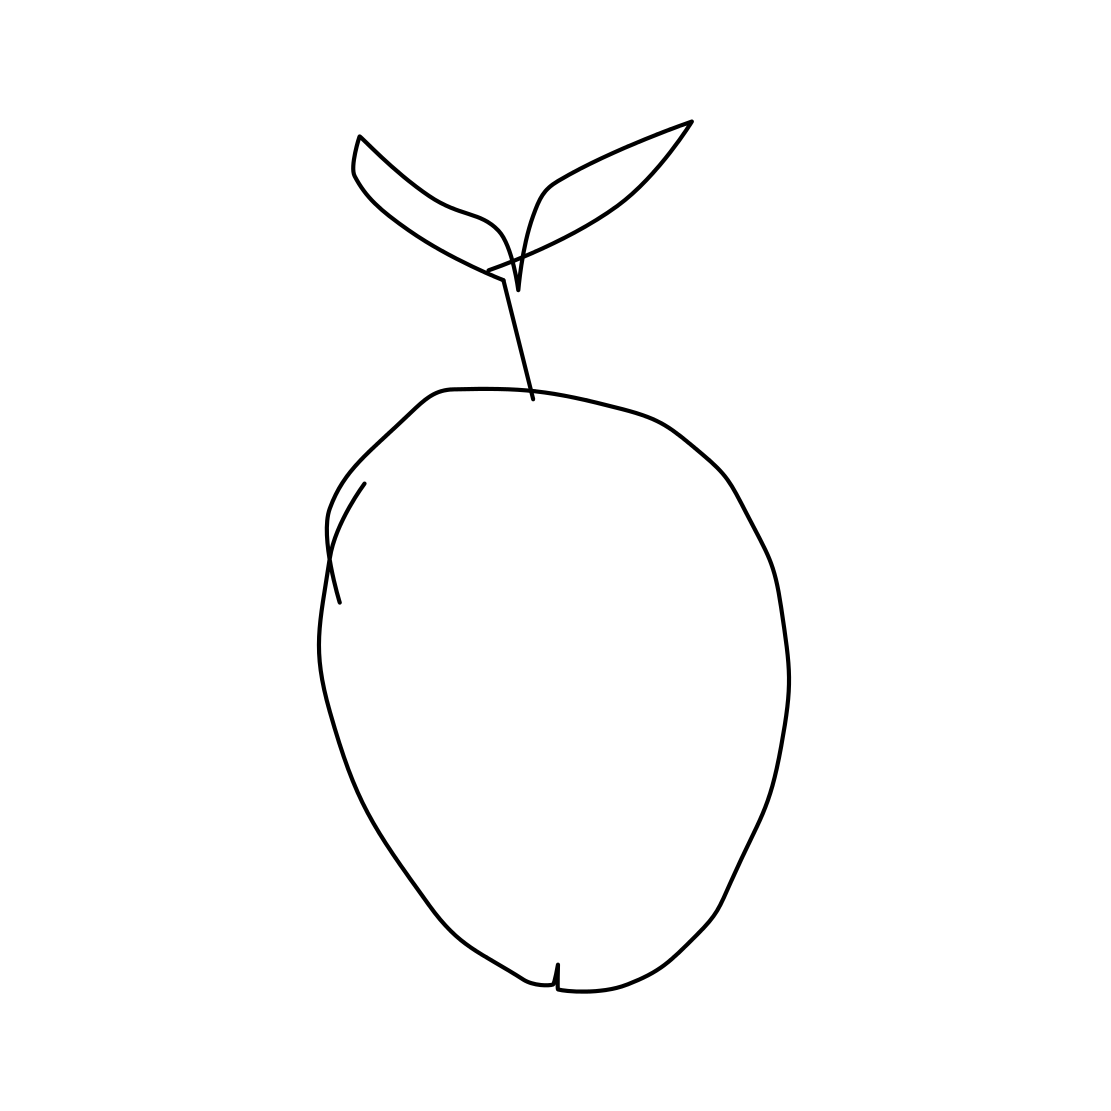In the scene, is a crab in it? No 